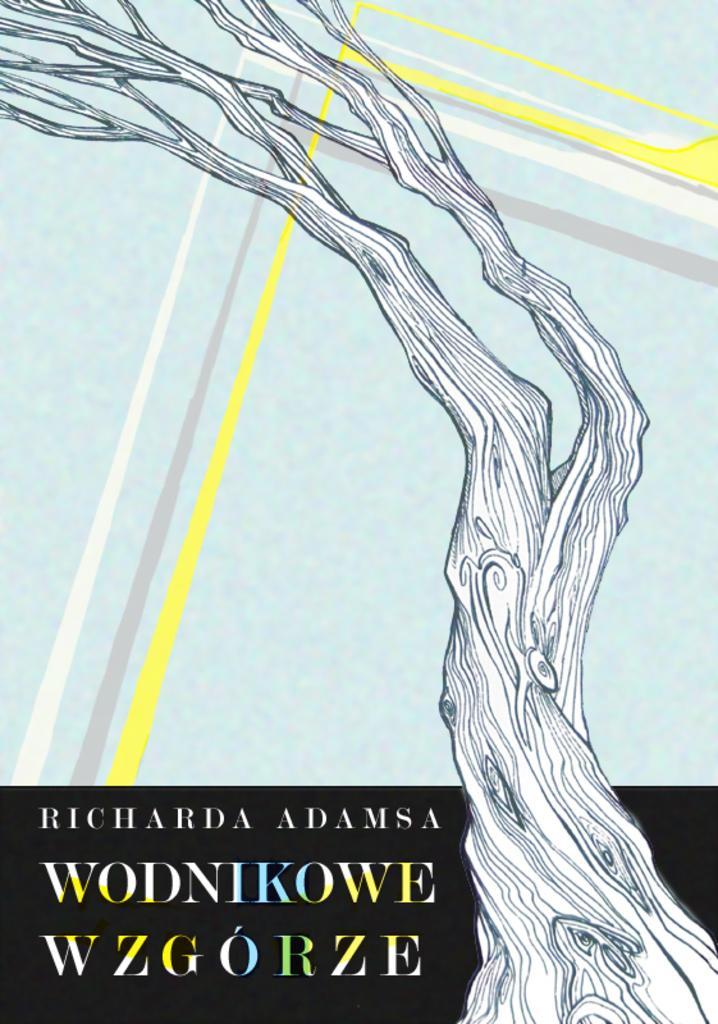Can you describe this image briefly? As we can see in the image there is a painting and drawing of a tree log and there are lines which are marked and which are in white, ash and yellow colour. Background is in light blue colour and there is a matter written over it. 